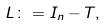Convert formula to latex. <formula><loc_0><loc_0><loc_500><loc_500>L \colon = I _ { n } - T ,</formula> 